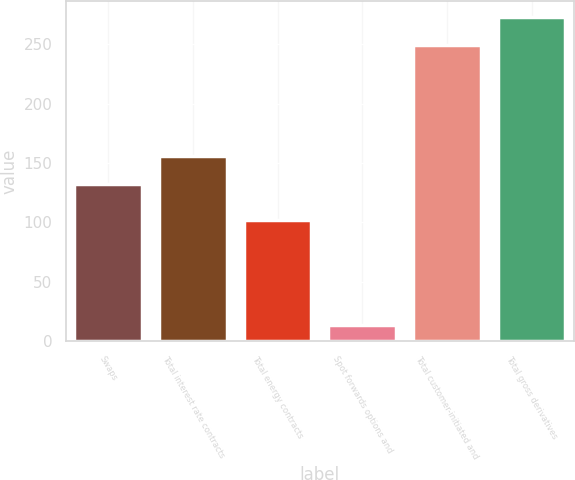Convert chart. <chart><loc_0><loc_0><loc_500><loc_500><bar_chart><fcel>Swaps<fcel>Total interest rate contracts<fcel>Total energy contracts<fcel>Spot forwards options and<fcel>Total customer-initiated and<fcel>Total gross derivatives<nl><fcel>132<fcel>155.5<fcel>102<fcel>14<fcel>249<fcel>272.5<nl></chart> 